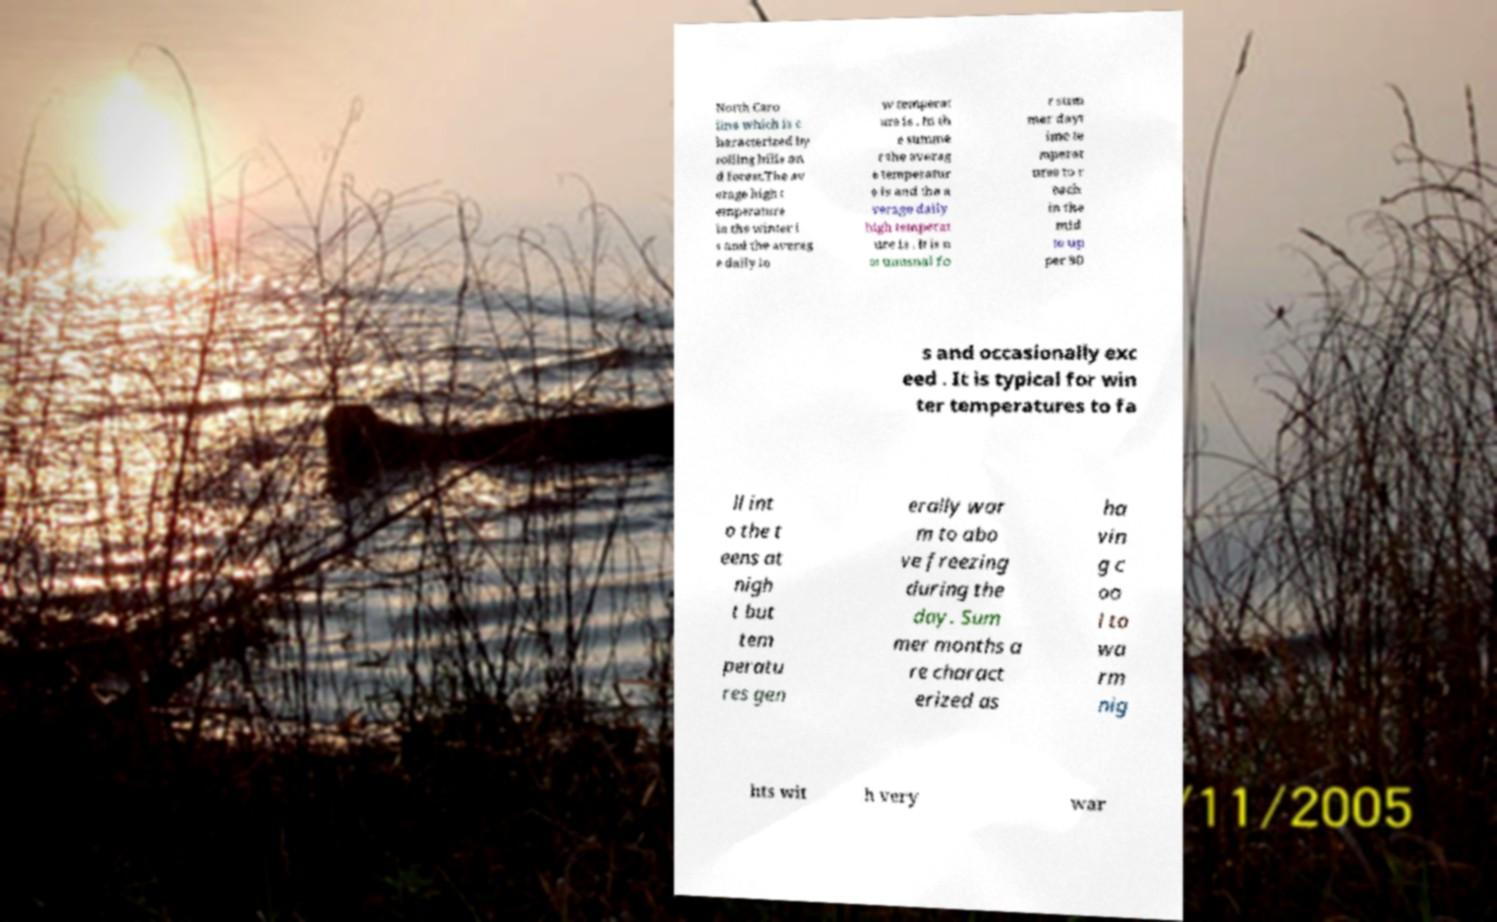Please read and relay the text visible in this image. What does it say? North Caro lina which is c haracterized by rolling hills an d forest.The av erage high t emperature in the winter i s and the averag e daily lo w temperat ure is . In th e summe r the averag e temperatur e is and the a verage daily high temperat ure is . It is n ot unusual fo r sum mer dayt ime te mperat ures to r each in the mid to up per 90 s and occasionally exc eed . It is typical for win ter temperatures to fa ll int o the t eens at nigh t but tem peratu res gen erally war m to abo ve freezing during the day. Sum mer months a re charact erized as ha vin g c oo l to wa rm nig hts wit h very war 